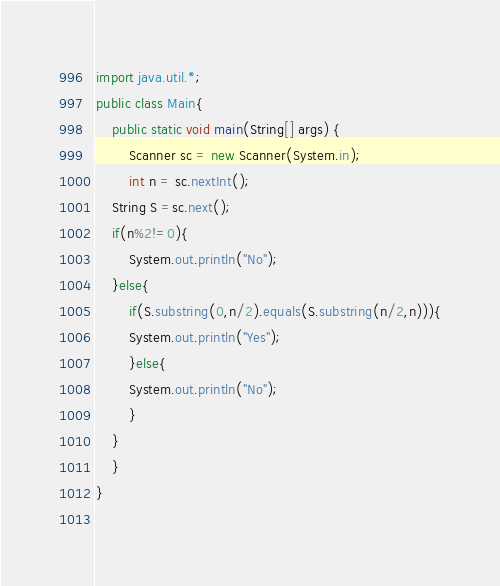<code> <loc_0><loc_0><loc_500><loc_500><_Java_>import java.util.*;
public class Main{
    public static void main(String[] args) {
        Scanner sc = new Scanner(System.in);
        int n = sc.nextInt();
	String S =sc.next();
	if(n%2!=0){
	    System.out.println("No");
	}else{
	    if(S.substring(0,n/2).equals(S.substring(n/2,n))){
		System.out.println("Yes");
	    }else{
		System.out.println("No");
	    }
	}
    }
}
	       
</code> 